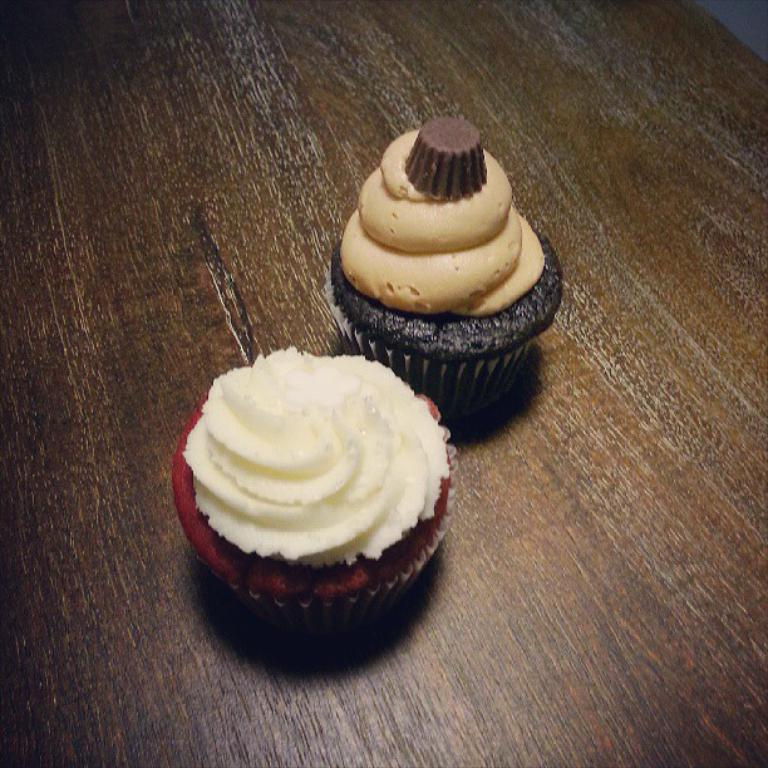How many cupcakes are in the image? There are two cupcakes in the image. What is the surface on which the cupcakes are placed? The cupcakes are placed on a wooden surface. What is on top of the cupcakes? The cupcakes have cream on them. Is there any wrapping around the cupcakes? Yes, there is a paper around the cupcakes. What is the cupcakes' reaction when they are asked to stop in the image? The cupcakes are inanimate objects and cannot react or be asked to stop. 